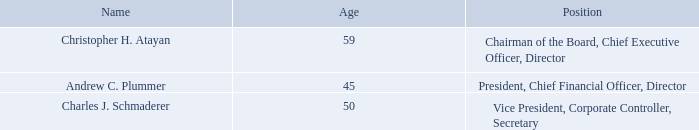EXECUTIVE OFFICERS OF THE REGISTRANT
Executive officers of our Company are appointed by the Board of Directors and serve at the discretion of the Board. The following table sets forth certain information with respect to all executive officers of our Company.
CHRISTOPHER H. ATAYAN has served in various senior executive positions with the Company since March 2006, including his service as Chairman of the Board since January 2008 and Chief Executive Officer since October 2006, and has been a director of the Company since 2004. Mr. Atayan has served as the Senior Managing Director of Slusser Associates, a private equity and investment banking firm, since 1988, and has been engaged in private equity and investment banking since 1982. He also serves on the Board of Eastek Holdings, LLC, a manufacturing company.
ANDREW C. PLUMMER has served as our President and Chief Operating Officer since October 2018, as our Chief Financial Officer since January 2007, and as our Secretary from January 2007 to October 2018. From 2004 to 2007, Mr. Plummer served our company in various roles including Acting Chief Financial Officer, Corporate Controller, and Manager of SEC Compliance. Prior to joining our company in 2004, Mr. Plummer practiced public accounting, primarily with the accounting firm Deloitte and Touche, LLP (now Deloitte).
CHARLES J. SCHMADERER has served as the Company’s Vice President and Corporate Controller since April 2018 and as Secretary since October 2018. From 2006 to 2018, Mr. Schmaderer served the Company in various roles including as the Vice President of Financial Reporting and Assistant Secretary, and as the Director of Financial and SEC Reporting. Prior to joining AMCON in 2006, Mr. Schmaderer practiced public accounting, primarily with the accounting firm Grant Thornton, LLP and also holds a Master of Business Administration (MBA).
How old are the company's executive officers? 59, 45, 50. Who are the executive officers of the company? Christopher h. atayan, andrew c. plummer, charles j. schmaderer. Where did Charles J. Schmaderer practice public accounting at? Grant thornton, llp. What is the average age of the company's executive officers? (59 + 45 + 50)/3 
Answer: 51.33. What is the average age of the company's President and Vice President? (45 + 50)/2 
Answer: 47.5. What is the average age of the company's Chief Executive and Chief Financial Officers? (59 + 45)/2 
Answer: 52. 